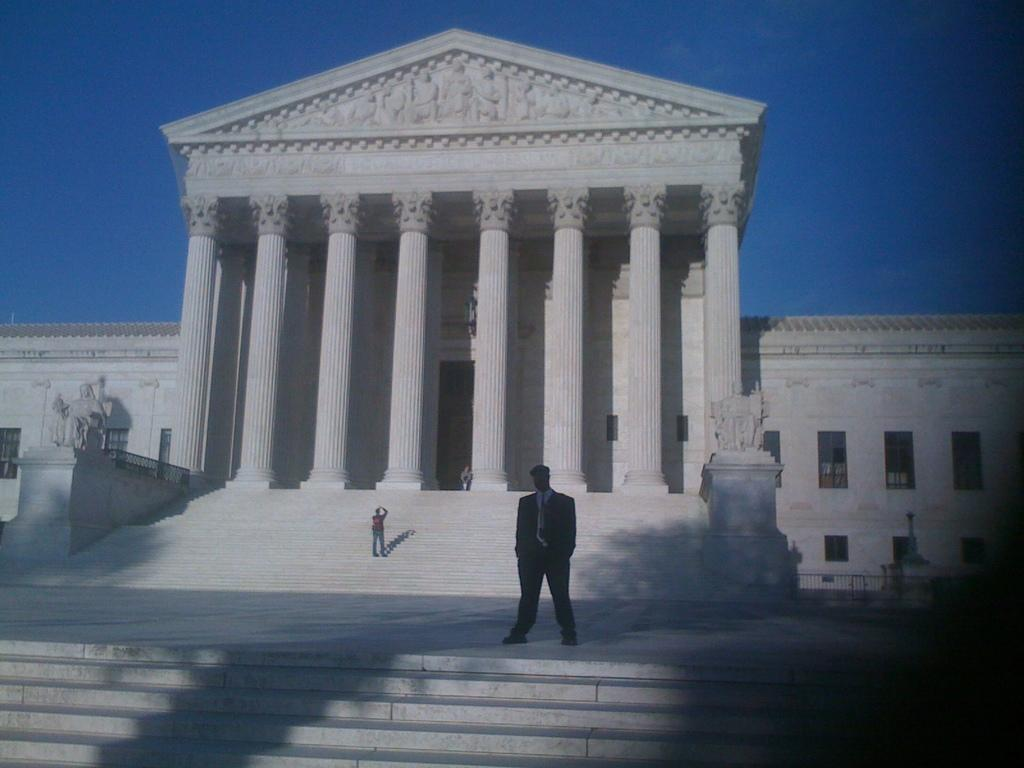What is the main subject in the middle of the image? There is a man standing in the middle of the image. What is the man wearing in the image? The man is wearing a coat, trousers, shirt, and tie. What structure can be seen in the image besides the man? There is a monument in the image. What is the color of the monument? The monument is white in color. What is visible at the top of the image? The sky is visible at the top of the image. What invention does the man have in his hand in the image? There is no invention visible in the man's hand in the image. What rule does the monument enforce in the image? The monument does not enforce any rule in the image; it is a stationary structure. 